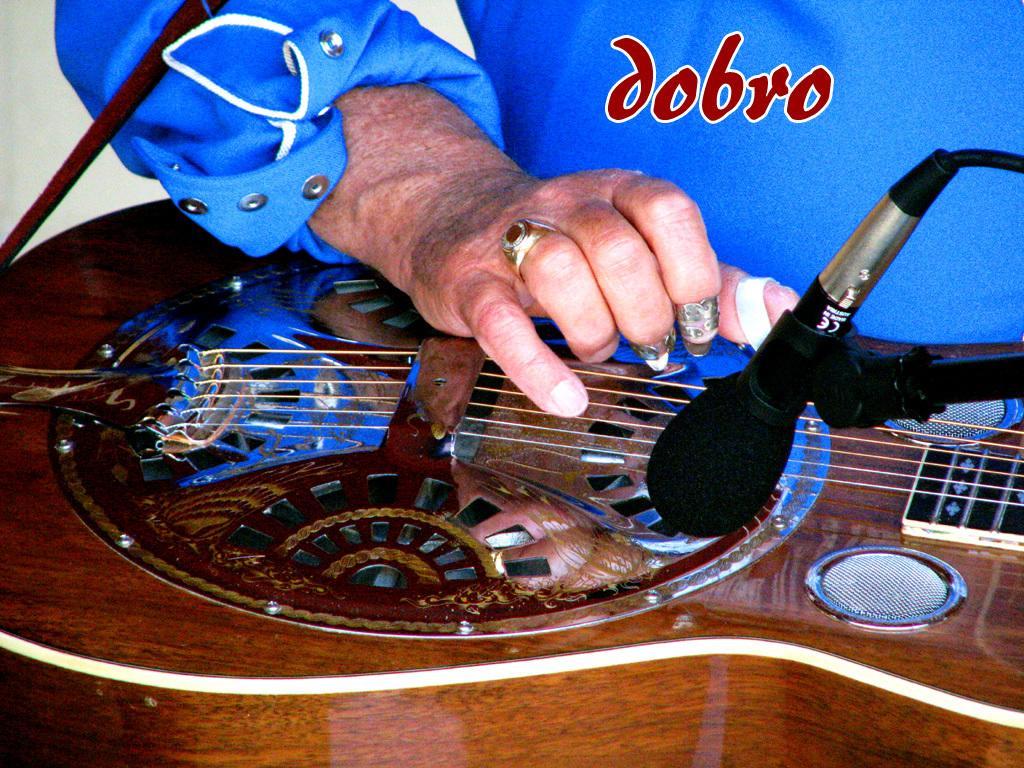Can you describe this image briefly? In this picture we can see a person is playing a guitar with his fingers. This is a mike. 